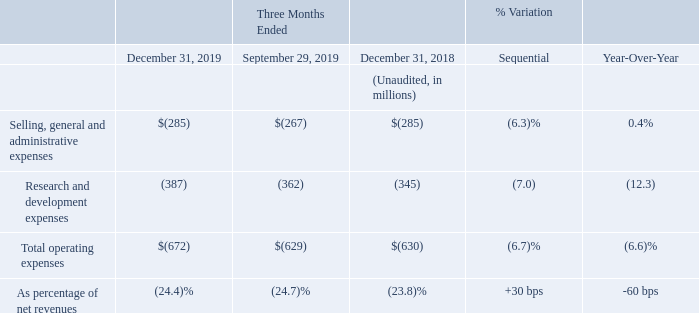The amount of our operating expenses increased by $43 million on a sequential basis, mainly driven by seasonality and salary dynamic.
On a year-over-year basis, our operating expenses increased by $42 million, mainly due to salary dynamic and increased spending on certain R&D programs, partially offset by favorable currency effects, net of hedging.
Fourth quarter 2019 R&D expenses were net of research tax credits in France and Italy, which amounted to $37 million, compared to $29 million in the third quarter of 2019 and $39 million in the fourth quarter of 2018.
Why did on sequential basis the operating expenses increased? Driven by seasonality and salary dynamic. Why did on year-over-year basis the operating expenses increased? Mainly due to salary dynamic and increased spending on certain r&d programs, partially offset by favorable currency effects, net of hedging. How much did the R&D expenses account for in the fourth quarter of 2019? $37 million. What is the average Selling, general and administrative expenses for the period December 31, 2019 and September 29, 2019?
Answer scale should be: million. (285+267) / 2
Answer: 276. What is the average Research and development expenses for the period December 31, 2019 and 2018?
Answer scale should be: million. (387+345) / 2
Answer: 366. What is the increase/ (decrease) in total operating expenses from the period December 31, 2018 to 2019?
Answer scale should be: million. 672-630
Answer: 42. 